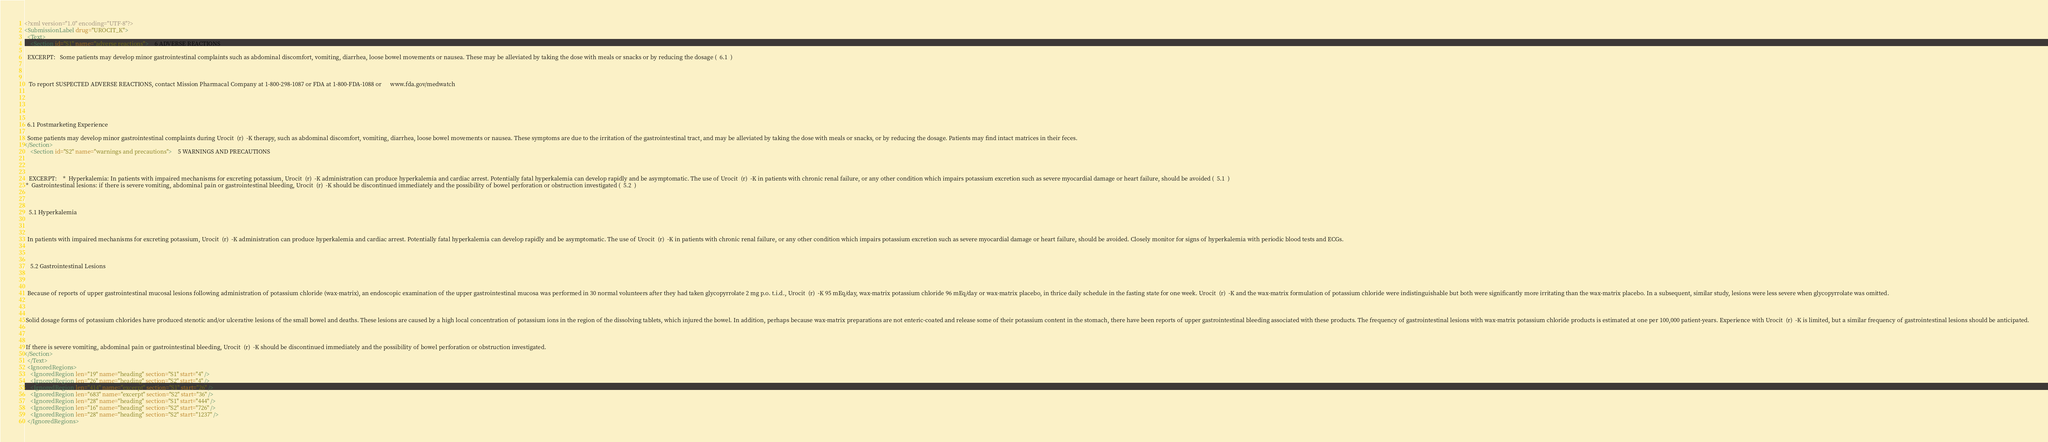<code> <loc_0><loc_0><loc_500><loc_500><_XML_><?xml version="1.0" encoding="UTF-8"?>
<SubmissionLabel drug="UROCIT_K">
  <Text>
    <Section id="S1" name="adverse reactions">    6 ADVERSE REACTIONS

  EXCERPT:   Some patients may develop minor gastrointestinal complaints such as abdominal discomfort, vomiting, diarrhea, loose bowel movements or nausea. These may be alleviated by taking the dose with meals or snacks or by reducing the dosage (  6.1  )



   To report SUSPECTED ADVERSE REACTIONS, contact Mission Pharmacal Company at 1-800-298-1087 or FDA at 1-800-FDA-1088 or      www.fda.gov/medwatch    



 

  6.1 Postmarketing Experience

  Some patients may develop minor gastrointestinal complaints during Urocit  (r)  -K therapy, such as abdominal discomfort, vomiting, diarrhea, loose bowel movements or nausea. These symptoms are due to the irritation of the gastrointestinal tract, and may be alleviated by taking the dose with meals or snacks, or by reducing the dosage. Patients may find intact matrices in their feces.
</Section>
    <Section id="S2" name="warnings and precautions">    5 WARNINGS AND PRECAUTIONS



   EXCERPT:    *  Hyperkalemia: In patients with impaired mechanisms for excreting potassium, Urocit  (r)  -K administration can produce hyperkalemia and cardiac arrest. Potentially fatal hyperkalemia can develop rapidly and be asymptomatic. The use of Urocit  (r)  -K in patients with chronic renal failure, or any other condition which impairs potassium excretion such as severe myocardial damage or heart failure, should be avoided (  5.1  ) 
 *  Gastrointestinal lesions: if there is severe vomiting, abdominal pain or gastrointestinal bleeding, Urocit  (r)  -K should be discontinued immediately and the possibility of bowel perforation or obstruction investigated (  5.2  ) 
    
 

   5.1 Hyperkalemia



  In patients with impaired mechanisms for excreting potassium, Urocit  (r)  -K administration can produce hyperkalemia and cardiac arrest. Potentially fatal hyperkalemia can develop rapidly and be asymptomatic. The use of Urocit  (r)  -K in patients with chronic renal failure, or any other condition which impairs potassium excretion such as severe myocardial damage or heart failure, should be avoided. Closely monitor for signs of hyperkalemia with periodic blood tests and ECGs.



    5.2 Gastrointestinal Lesions



  Because of reports of upper gastrointestinal mucosal lesions following administration of potassium chloride (wax-matrix), an endoscopic examination of the upper gastrointestinal mucosa was performed in 30 normal volunteers after they had taken glycopyrrolate 2 mg p.o. t.i.d., Urocit  (r)  -K 95 mEq/day, wax-matrix potassium chloride 96 mEq/day or wax-matrix placebo, in thrice daily schedule in the fasting state for one week. Urocit  (r)  -K and the wax-matrix formulation of potassium chloride were indistinguishable but both were significantly more irritating than the wax-matrix placebo. In a subsequent, similar study, lesions were less severe when glycopyrrolate was omitted.



 Solid dosage forms of potassium chlorides have produced stenotic and/or ulcerative lesions of the small bowel and deaths. These lesions are caused by a high local concentration of potassium ions in the region of the dissolving tablets, which injured the bowel. In addition, perhaps because wax-matrix preparations are not enteric-coated and release some of their potassium content in the stomach, there have been reports of upper gastrointestinal bleeding associated with these products. The frequency of gastrointestinal lesions with wax-matrix potassium chloride products is estimated at one per 100,000 patient-years. Experience with Urocit  (r)  -K is limited, but a similar frequency of gastrointestinal lesions should be anticipated.



 If there is severe vomiting, abdominal pain or gastrointestinal bleeding, Urocit  (r)  -K should be discontinued immediately and the possibility of bowel perforation or obstruction investigated.
</Section>
  </Text>
  <IgnoredRegions>
    <IgnoredRegion len="19" name="heading" section="S1" start="4" />
    <IgnoredRegion len="26" name="heading" section="S2" start="4" />
    <IgnoredRegion len="414" name="excerpt" section="S1" start="26" />
    <IgnoredRegion len="683" name="excerpt" section="S2" start="36" />
    <IgnoredRegion len="28" name="heading" section="S1" start="444" />
    <IgnoredRegion len="16" name="heading" section="S2" start="726" />
    <IgnoredRegion len="28" name="heading" section="S2" start="1237" />
  </IgnoredRegions></code> 